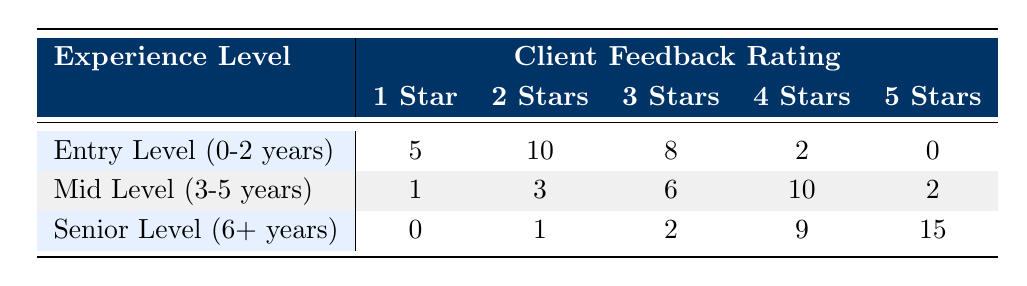What is the number of photographers at the Senior Level who received a 5 Star rating? In the table, the Senior Level (6+ years) row shows that the count for 5 Stars is 15.
Answer: 15 How many Entry Level photographers received a 4 Star rating? The table lists 2 under the 4 Stars for the Entry Level (0-2 years) row.
Answer: 2 What is the total count of 1 Star ratings across all experience levels? Summing the counts for 1 Star ratings: 5 (Entry Level) + 1 (Mid Level) + 0 (Senior Level) = 6.
Answer: 6 Are there any photographers at the Senior Level who received a 1 Star rating? The table indicates that the count for 1 Star ratings at the Senior Level (6+ years) is 0. Therefore, there are none.
Answer: No Which experience level has the highest count of 3 Star ratings, and what is that count? The counts for 3 Star ratings are: Entry Level has 8, Mid Level has 6, and Senior Level has 2. Entry Level has the highest count of 8.
Answer: Entry Level, 8 What is the average count of 2 Star ratings across all experience levels? The 2 Star counts are 10 (Entry Level) + 3 (Mid Level) + 1 (Senior Level) = 14. There are three experience levels, so the average is 14/3 = 4.67.
Answer: 4.67 What is the difference in 4 Star ratings between the Mid Level and Senior Level photographers? The Mid Level has 10 counts for 4 Stars and the Senior Level has 9 counts. The difference is 10 - 9 = 1.
Answer: 1 Which experience level has received the least amount of total ratings? To determine this, we sum counts for all ratings per level: Entry Level (5 + 10 + 8 + 2 + 0 = 25), Mid Level (1 + 3 + 6 + 10 + 2 = 22), Senior Level (0 + 1 + 2 + 9 + 15 = 27). Mid Level has the least at 22.
Answer: Mid Level What percentage of Senior Level photographers received a 5 Star rating compared to the total ratings for that level? The total count at Senior Level is 0 + 1 + 2 + 9 + 15 = 27. The count for 5 Stars is 15. The percentage is (15/27) * 100 ≈ 55.56%.
Answer: 55.56% 